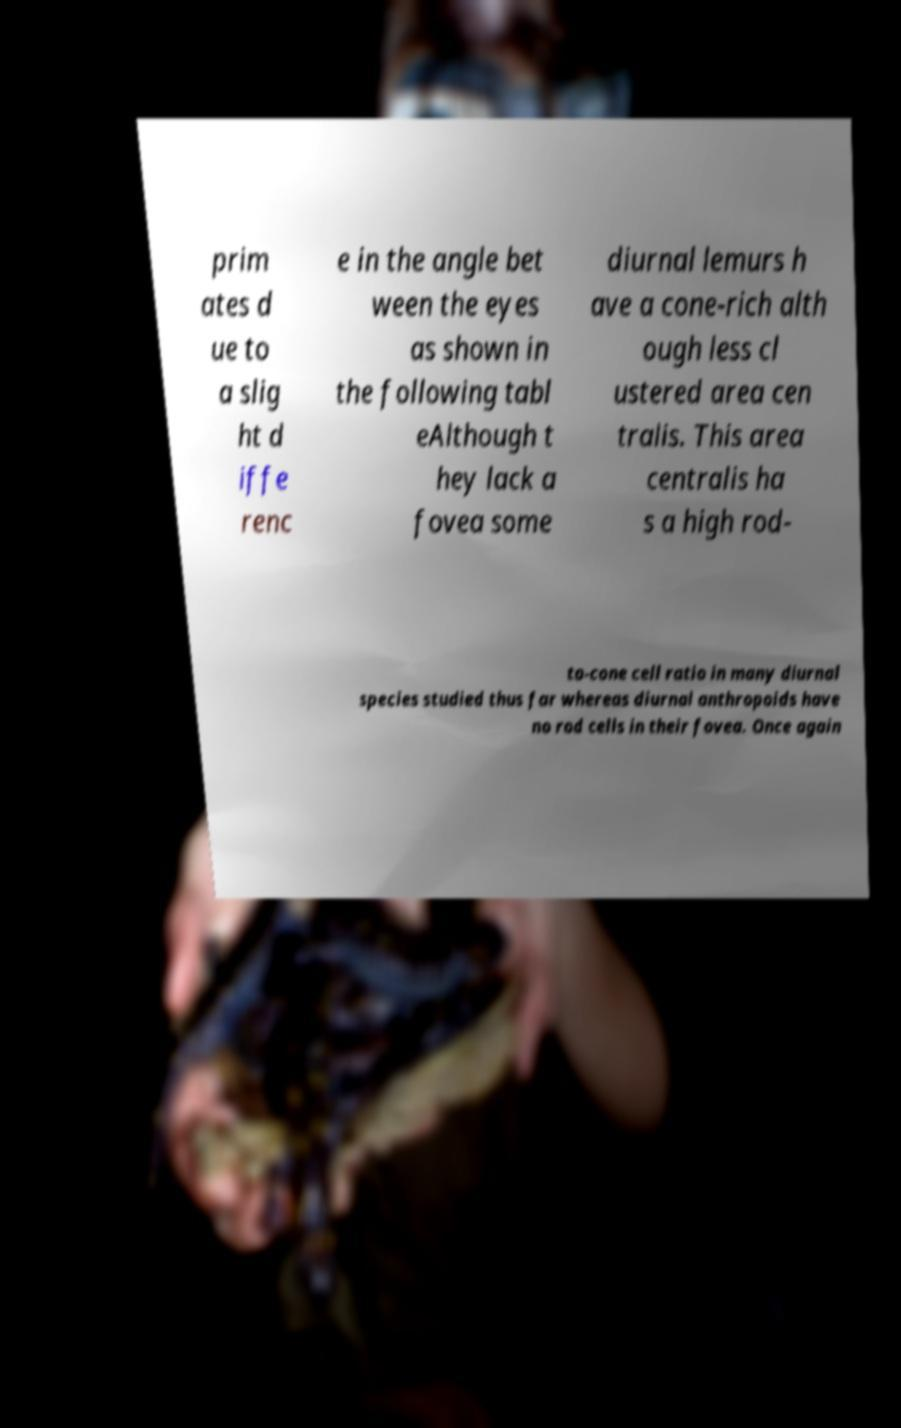Please identify and transcribe the text found in this image. prim ates d ue to a slig ht d iffe renc e in the angle bet ween the eyes as shown in the following tabl eAlthough t hey lack a fovea some diurnal lemurs h ave a cone-rich alth ough less cl ustered area cen tralis. This area centralis ha s a high rod- to-cone cell ratio in many diurnal species studied thus far whereas diurnal anthropoids have no rod cells in their fovea. Once again 